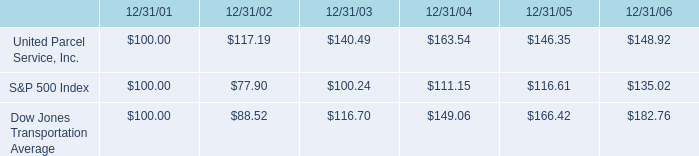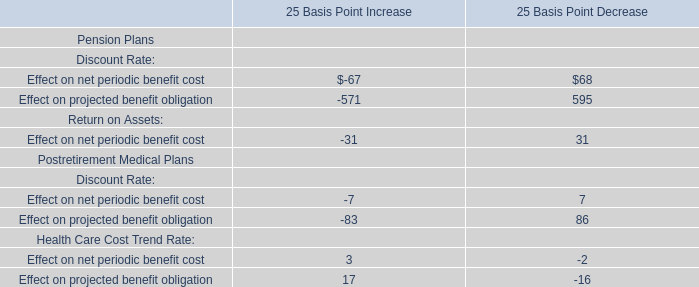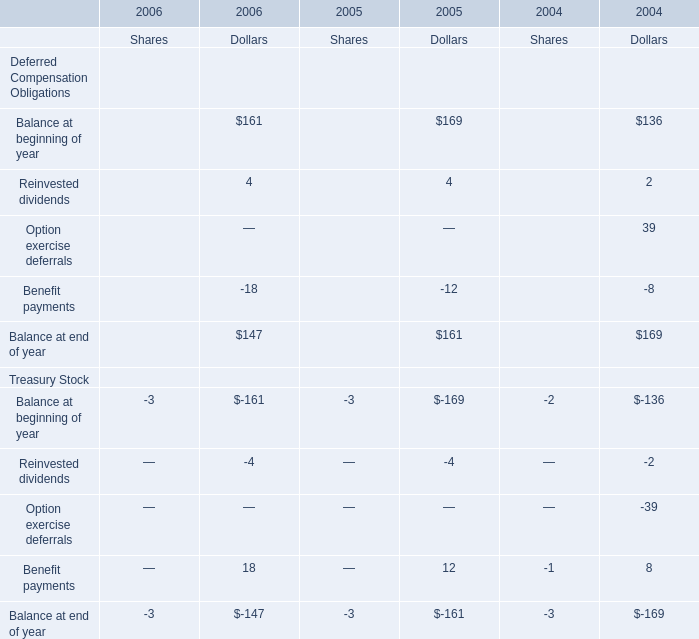what was the percentage total cumulative return on investment for united parcel service inc . for the five years ended 12/31/06? 
Computations: ((148.92 - 100) / 100)
Answer: 0.4892. 